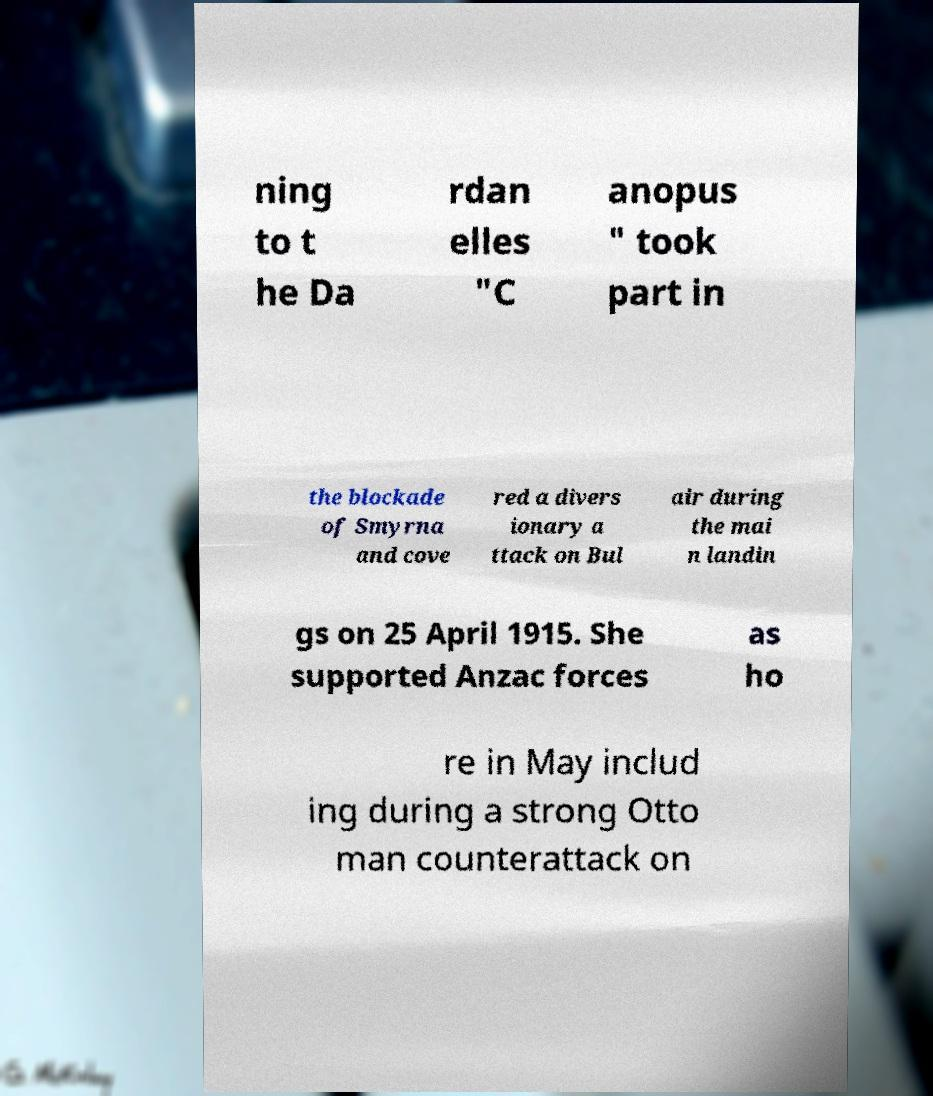Could you assist in decoding the text presented in this image and type it out clearly? ning to t he Da rdan elles "C anopus " took part in the blockade of Smyrna and cove red a divers ionary a ttack on Bul air during the mai n landin gs on 25 April 1915. She supported Anzac forces as ho re in May includ ing during a strong Otto man counterattack on 